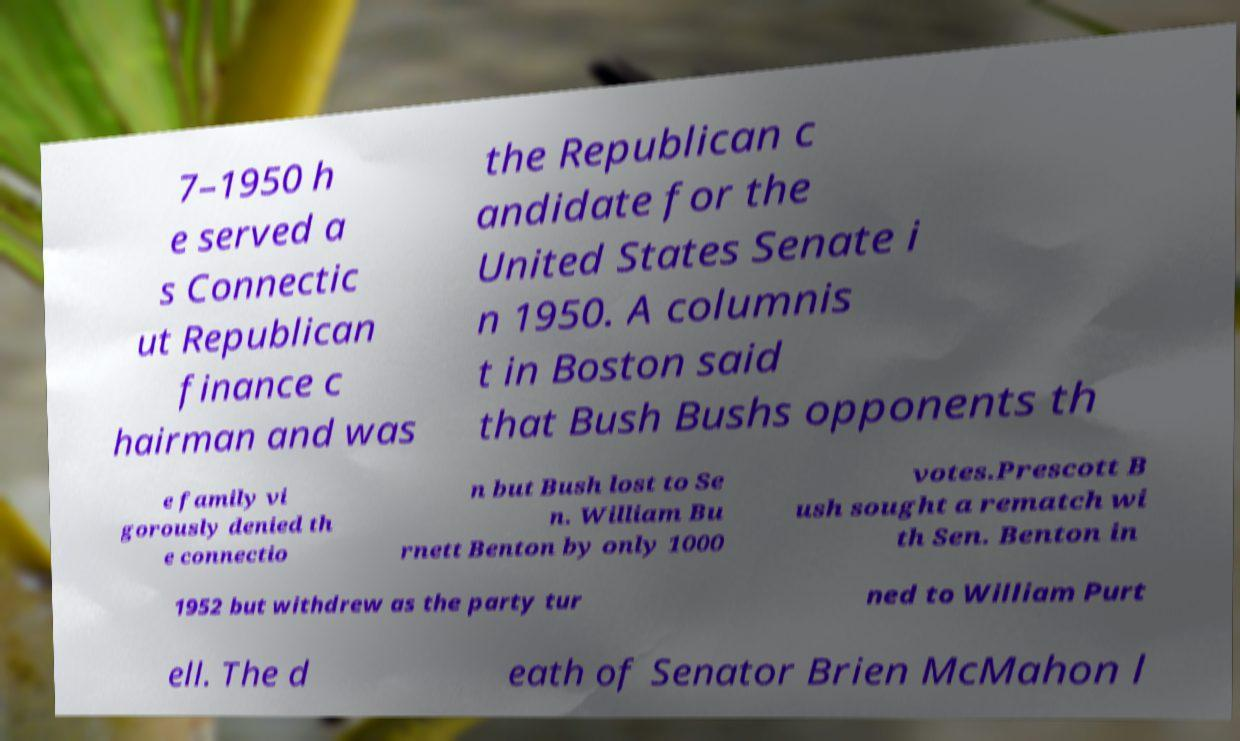For documentation purposes, I need the text within this image transcribed. Could you provide that? 7–1950 h e served a s Connectic ut Republican finance c hairman and was the Republican c andidate for the United States Senate i n 1950. A columnis t in Boston said that Bush Bushs opponents th e family vi gorously denied th e connectio n but Bush lost to Se n. William Bu rnett Benton by only 1000 votes.Prescott B ush sought a rematch wi th Sen. Benton in 1952 but withdrew as the party tur ned to William Purt ell. The d eath of Senator Brien McMahon l 